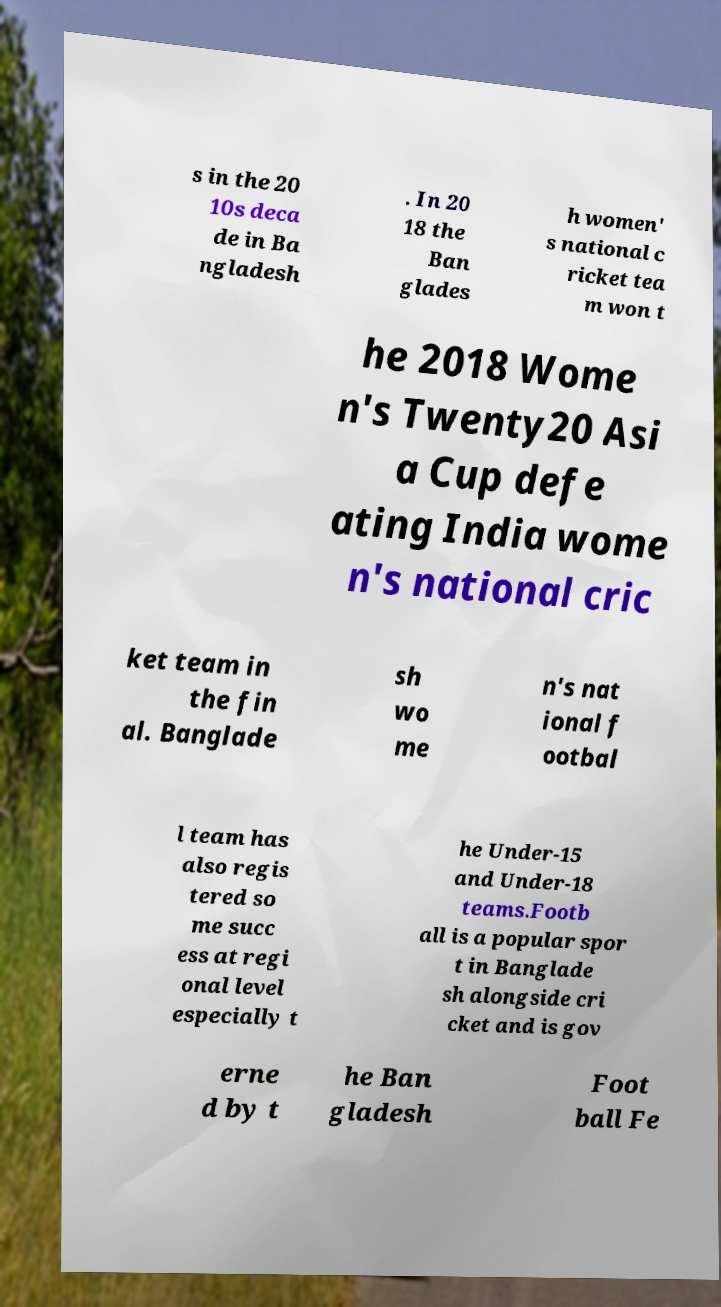For documentation purposes, I need the text within this image transcribed. Could you provide that? s in the 20 10s deca de in Ba ngladesh . In 20 18 the Ban glades h women' s national c ricket tea m won t he 2018 Wome n's Twenty20 Asi a Cup defe ating India wome n's national cric ket team in the fin al. Banglade sh wo me n's nat ional f ootbal l team has also regis tered so me succ ess at regi onal level especially t he Under-15 and Under-18 teams.Footb all is a popular spor t in Banglade sh alongside cri cket and is gov erne d by t he Ban gladesh Foot ball Fe 